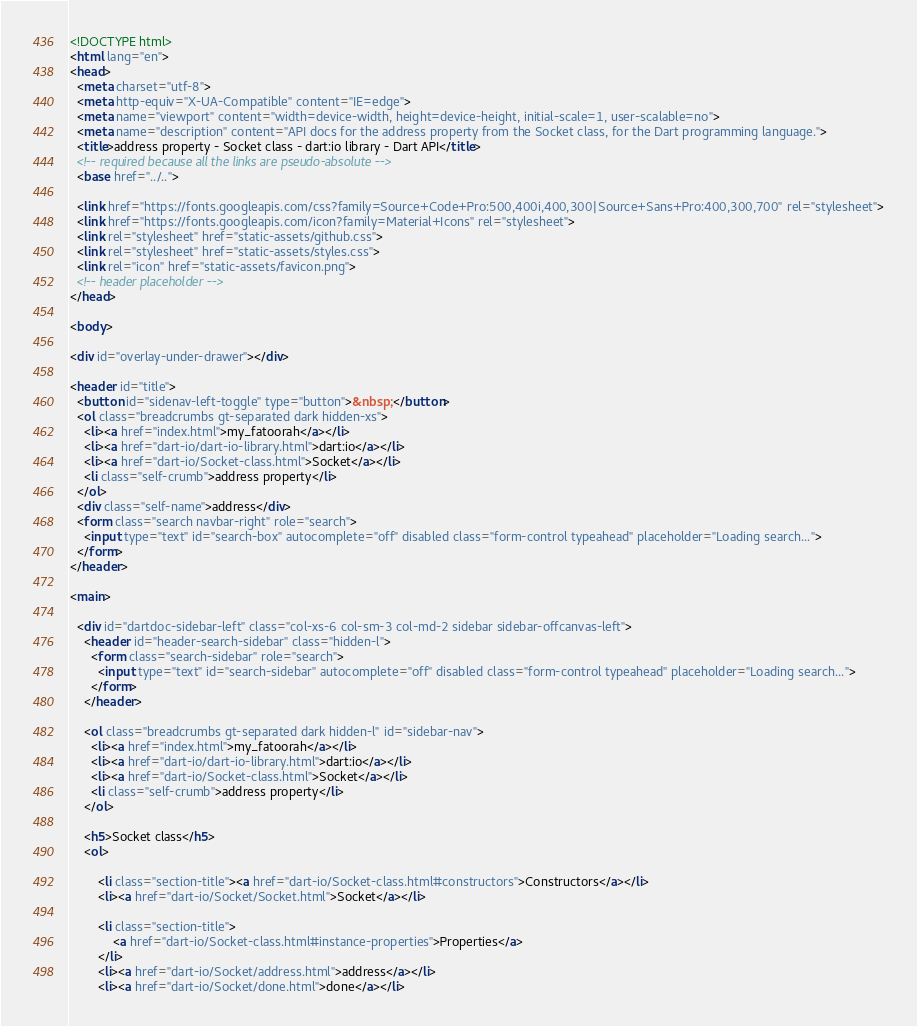<code> <loc_0><loc_0><loc_500><loc_500><_HTML_><!DOCTYPE html>
<html lang="en">
<head>
  <meta charset="utf-8">
  <meta http-equiv="X-UA-Compatible" content="IE=edge">
  <meta name="viewport" content="width=device-width, height=device-height, initial-scale=1, user-scalable=no">
  <meta name="description" content="API docs for the address property from the Socket class, for the Dart programming language.">
  <title>address property - Socket class - dart:io library - Dart API</title>
  <!-- required because all the links are pseudo-absolute -->
  <base href="../..">

  <link href="https://fonts.googleapis.com/css?family=Source+Code+Pro:500,400i,400,300|Source+Sans+Pro:400,300,700" rel="stylesheet">
  <link href="https://fonts.googleapis.com/icon?family=Material+Icons" rel="stylesheet">
  <link rel="stylesheet" href="static-assets/github.css">
  <link rel="stylesheet" href="static-assets/styles.css">
  <link rel="icon" href="static-assets/favicon.png">
  <!-- header placeholder -->
</head>

<body>

<div id="overlay-under-drawer"></div>

<header id="title">
  <button id="sidenav-left-toggle" type="button">&nbsp;</button>
  <ol class="breadcrumbs gt-separated dark hidden-xs">
    <li><a href="index.html">my_fatoorah</a></li>
    <li><a href="dart-io/dart-io-library.html">dart:io</a></li>
    <li><a href="dart-io/Socket-class.html">Socket</a></li>
    <li class="self-crumb">address property</li>
  </ol>
  <div class="self-name">address</div>
  <form class="search navbar-right" role="search">
    <input type="text" id="search-box" autocomplete="off" disabled class="form-control typeahead" placeholder="Loading search...">
  </form>
</header>

<main>

  <div id="dartdoc-sidebar-left" class="col-xs-6 col-sm-3 col-md-2 sidebar sidebar-offcanvas-left">
    <header id="header-search-sidebar" class="hidden-l">
      <form class="search-sidebar" role="search">
        <input type="text" id="search-sidebar" autocomplete="off" disabled class="form-control typeahead" placeholder="Loading search...">
      </form>
    </header>
    
    <ol class="breadcrumbs gt-separated dark hidden-l" id="sidebar-nav">
      <li><a href="index.html">my_fatoorah</a></li>
      <li><a href="dart-io/dart-io-library.html">dart:io</a></li>
      <li><a href="dart-io/Socket-class.html">Socket</a></li>
      <li class="self-crumb">address property</li>
    </ol>
    
    <h5>Socket class</h5>
    <ol>
    
        <li class="section-title"><a href="dart-io/Socket-class.html#constructors">Constructors</a></li>
        <li><a href="dart-io/Socket/Socket.html">Socket</a></li>
    
        <li class="section-title">
            <a href="dart-io/Socket-class.html#instance-properties">Properties</a>
        </li>
        <li><a href="dart-io/Socket/address.html">address</a></li>
        <li><a href="dart-io/Socket/done.html">done</a></li></code> 